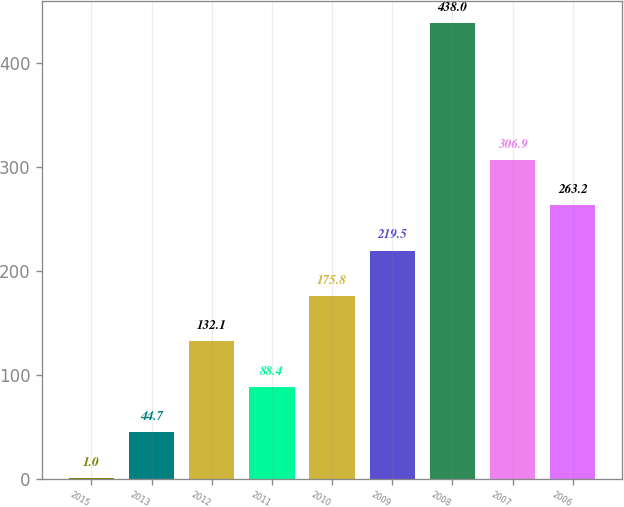Convert chart. <chart><loc_0><loc_0><loc_500><loc_500><bar_chart><fcel>2015<fcel>2013<fcel>2012<fcel>2011<fcel>2010<fcel>2009<fcel>2008<fcel>2007<fcel>2006<nl><fcel>1<fcel>44.7<fcel>132.1<fcel>88.4<fcel>175.8<fcel>219.5<fcel>438<fcel>306.9<fcel>263.2<nl></chart> 